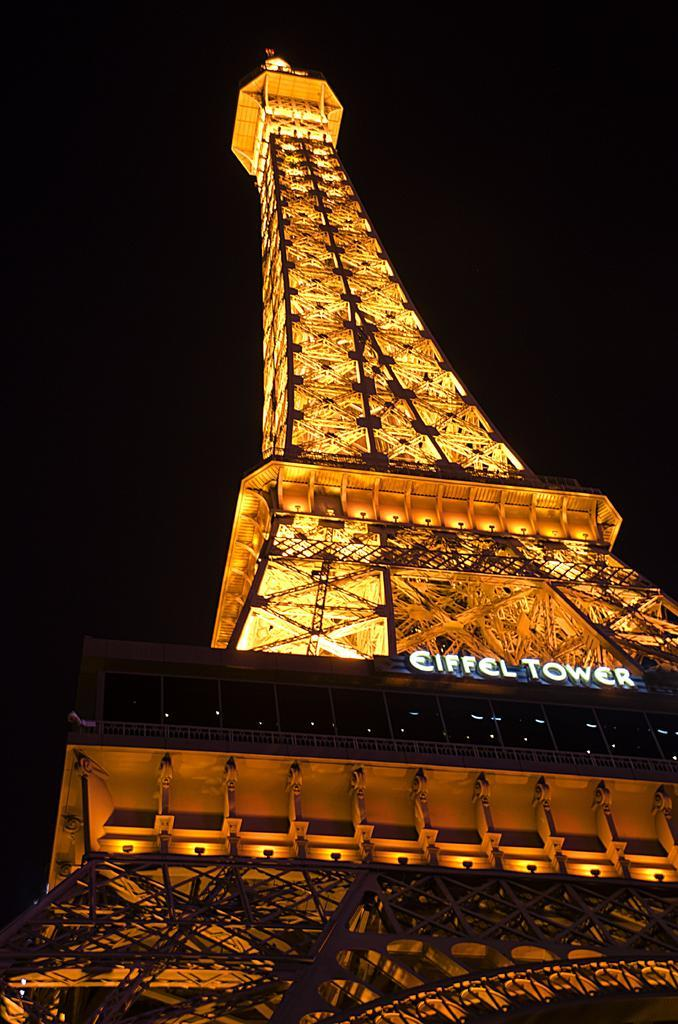What time of day was the image taken? The image was taken during night time. What famous landmark can be seen in the image? The Eiffel tower is present in the image. What can be observed in the image besides the Eiffel tower? There are lights visible in the image. What is the color of the background in the image? The background of the image is black. What type of chair is placed next to the Eiffel tower in the image? There is no chair present in the image; it only features the Eiffel tower and lights. What key is used to unlock the Eiffel tower in the image? There is no key or locking mechanism present in the image; the Eiffel tower is a landmark and not a locked object. 